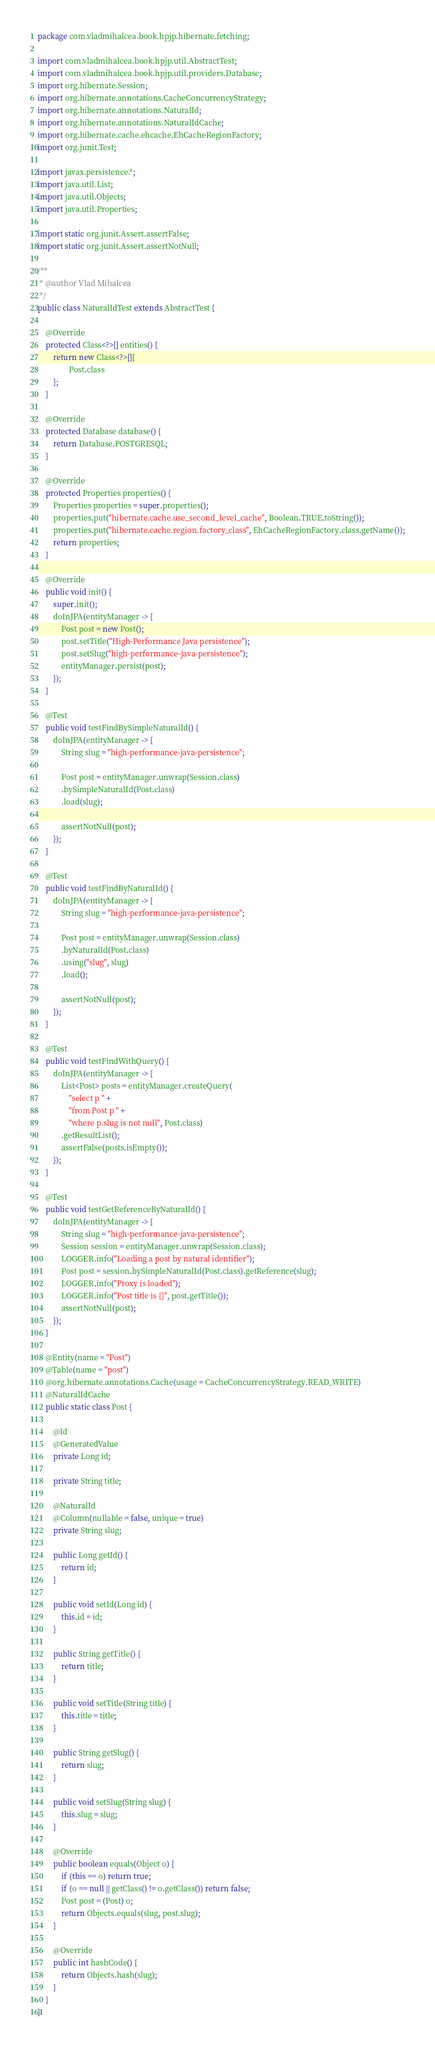Convert code to text. <code><loc_0><loc_0><loc_500><loc_500><_Java_>package com.vladmihalcea.book.hpjp.hibernate.fetching;

import com.vladmihalcea.book.hpjp.util.AbstractTest;
import com.vladmihalcea.book.hpjp.util.providers.Database;
import org.hibernate.Session;
import org.hibernate.annotations.CacheConcurrencyStrategy;
import org.hibernate.annotations.NaturalId;
import org.hibernate.annotations.NaturalIdCache;
import org.hibernate.cache.ehcache.EhCacheRegionFactory;
import org.junit.Test;

import javax.persistence.*;
import java.util.List;
import java.util.Objects;
import java.util.Properties;

import static org.junit.Assert.assertFalse;
import static org.junit.Assert.assertNotNull;

/**
 * @author Vlad Mihalcea
 */
public class NaturalIdTest extends AbstractTest {

    @Override
    protected Class<?>[] entities() {
        return new Class<?>[]{
                Post.class
        };
    }

    @Override
    protected Database database() {
        return Database.POSTGRESQL;
    }

    @Override
    protected Properties properties() {
        Properties properties = super.properties();
        properties.put("hibernate.cache.use_second_level_cache", Boolean.TRUE.toString());
        properties.put("hibernate.cache.region.factory_class", EhCacheRegionFactory.class.getName());
        return properties;
    }

    @Override
    public void init() {
        super.init();
        doInJPA(entityManager -> {
            Post post = new Post();
            post.setTitle("High-Performance Java persistence");
            post.setSlug("high-performance-java-persistence");
            entityManager.persist(post);
        });
    }

    @Test
    public void testFindBySimpleNaturalId() {
        doInJPA(entityManager -> {
            String slug = "high-performance-java-persistence";

            Post post = entityManager.unwrap(Session.class)
            .bySimpleNaturalId(Post.class)
            .load(slug);

            assertNotNull(post);
        });
    }

    @Test
    public void testFindByNaturalId() {
        doInJPA(entityManager -> {
            String slug = "high-performance-java-persistence";

            Post post = entityManager.unwrap(Session.class)
            .byNaturalId(Post.class)
            .using("slug", slug)
            .load();

            assertNotNull(post);
        });
    }

    @Test
    public void testFindWithQuery() {
        doInJPA(entityManager -> {
            List<Post> posts = entityManager.createQuery(
                "select p " +
                "from Post p " +
                "where p.slug is not null", Post.class)
            .getResultList();
            assertFalse(posts.isEmpty());
        });
    }

    @Test
    public void testGetReferenceByNaturalId() {
        doInJPA(entityManager -> {
            String slug = "high-performance-java-persistence";
            Session session = entityManager.unwrap(Session.class);
            LOGGER.info("Loading a post by natural identifier");
            Post post = session.bySimpleNaturalId(Post.class).getReference(slug);
            LOGGER.info("Proxy is loaded");
            LOGGER.info("Post title is {}", post.getTitle());
            assertNotNull(post);
        });
    }

    @Entity(name = "Post")
    @Table(name = "post")
    @org.hibernate.annotations.Cache(usage = CacheConcurrencyStrategy.READ_WRITE)
    @NaturalIdCache
    public static class Post {

        @Id
        @GeneratedValue
        private Long id;

        private String title;

        @NaturalId
        @Column(nullable = false, unique = true)
        private String slug;

        public Long getId() {
            return id;
        }

        public void setId(Long id) {
            this.id = id;
        }

        public String getTitle() {
            return title;
        }

        public void setTitle(String title) {
            this.title = title;
        }

        public String getSlug() {
            return slug;
        }

        public void setSlug(String slug) {
            this.slug = slug;
        }

        @Override
        public boolean equals(Object o) {
            if (this == o) return true;
            if (o == null || getClass() != o.getClass()) return false;
            Post post = (Post) o;
            return Objects.equals(slug, post.slug);
        }

        @Override
        public int hashCode() {
            return Objects.hash(slug);
        }
    }
}
</code> 